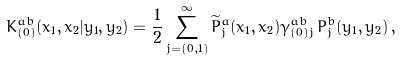Convert formula to latex. <formula><loc_0><loc_0><loc_500><loc_500>K _ { ( 0 ) } ^ { a b } ( x _ { 1 } , x _ { 2 } | y _ { 1 } , y _ { 2 } ) = \frac { 1 } { 2 } \sum _ { j = ( 0 , 1 ) } ^ { \infty } \widetilde { P } ^ { a } _ { j } ( x _ { 1 } , x _ { 2 } ) \gamma _ { ( 0 ) j } ^ { a b } \, P ^ { b } _ { j } ( y _ { 1 } , y _ { 2 } ) \, ,</formula> 